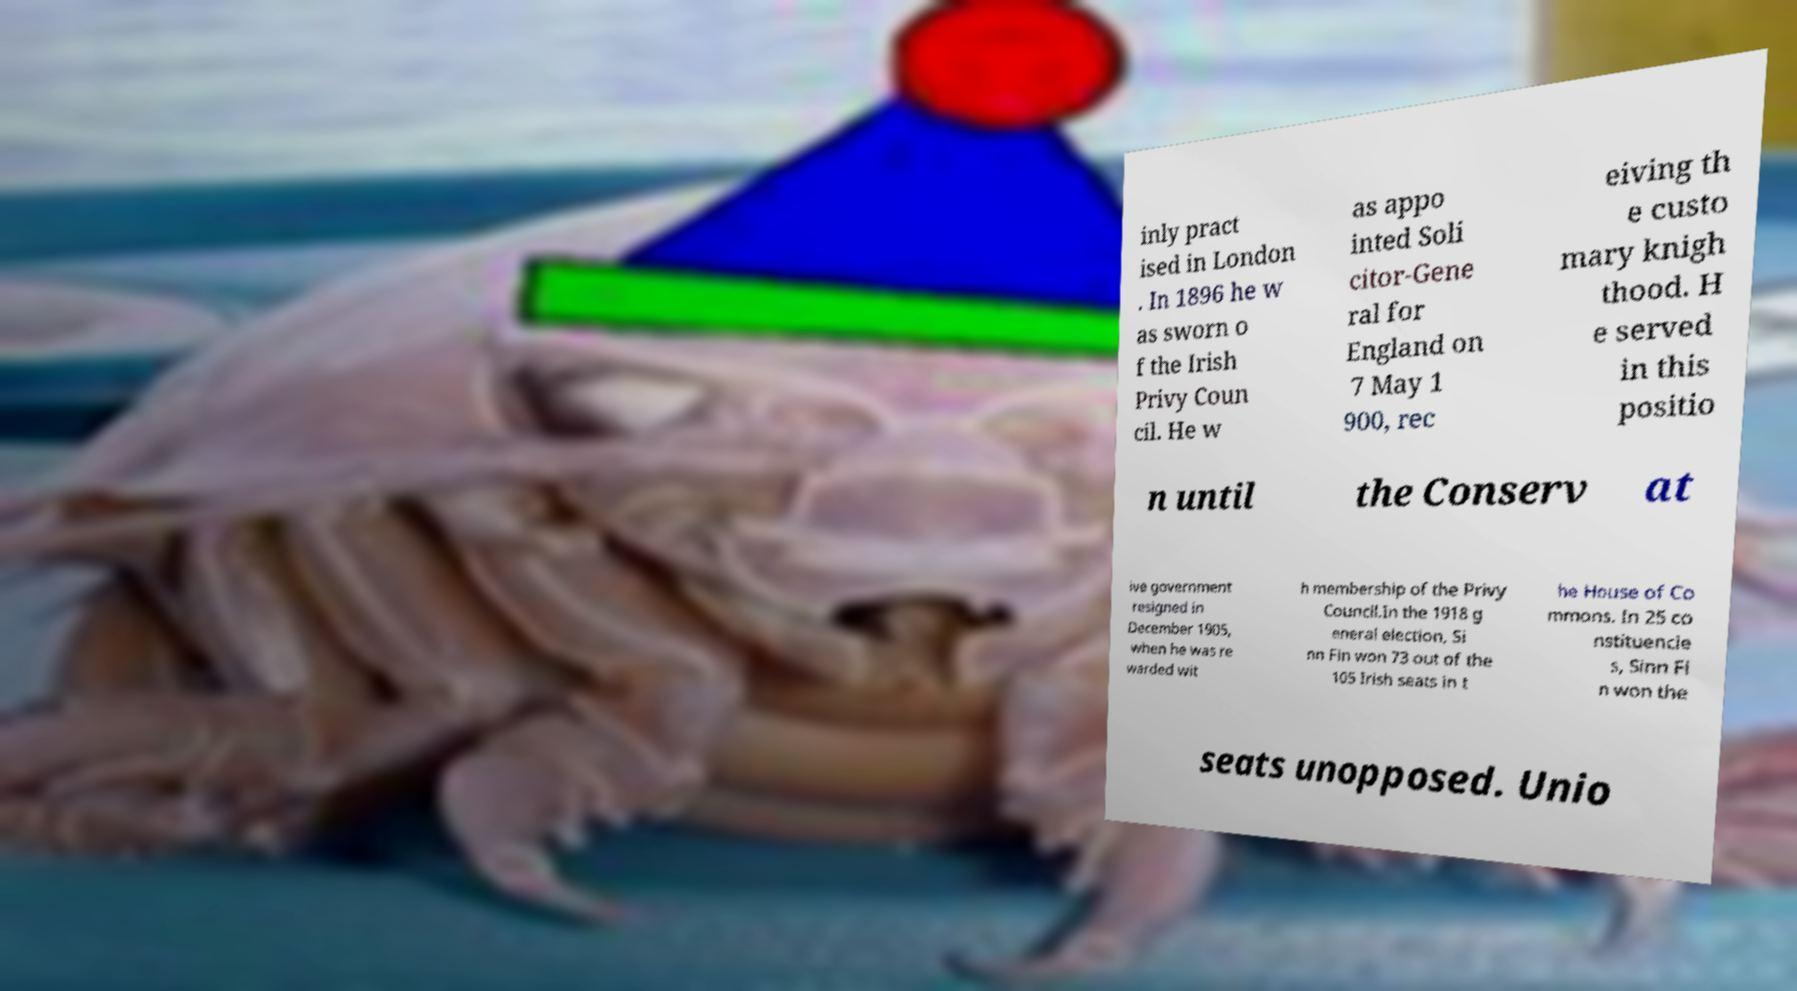What messages or text are displayed in this image? I need them in a readable, typed format. inly pract ised in London . In 1896 he w as sworn o f the Irish Privy Coun cil. He w as appo inted Soli citor-Gene ral for England on 7 May 1 900, rec eiving th e custo mary knigh thood. H e served in this positio n until the Conserv at ive government resigned in December 1905, when he was re warded wit h membership of the Privy Council.In the 1918 g eneral election, Si nn Fin won 73 out of the 105 Irish seats in t he House of Co mmons. In 25 co nstituencie s, Sinn Fi n won the seats unopposed. Unio 